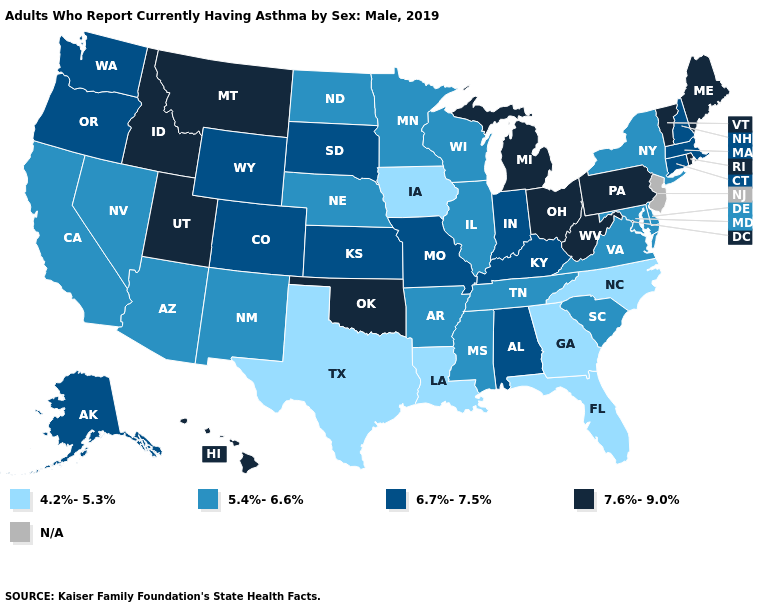What is the highest value in the West ?
Be succinct. 7.6%-9.0%. Name the states that have a value in the range 5.4%-6.6%?
Answer briefly. Arizona, Arkansas, California, Delaware, Illinois, Maryland, Minnesota, Mississippi, Nebraska, Nevada, New Mexico, New York, North Dakota, South Carolina, Tennessee, Virginia, Wisconsin. Name the states that have a value in the range 4.2%-5.3%?
Quick response, please. Florida, Georgia, Iowa, Louisiana, North Carolina, Texas. Among the states that border Mississippi , which have the highest value?
Short answer required. Alabama. Name the states that have a value in the range 5.4%-6.6%?
Quick response, please. Arizona, Arkansas, California, Delaware, Illinois, Maryland, Minnesota, Mississippi, Nebraska, Nevada, New Mexico, New York, North Dakota, South Carolina, Tennessee, Virginia, Wisconsin. Name the states that have a value in the range 6.7%-7.5%?
Keep it brief. Alabama, Alaska, Colorado, Connecticut, Indiana, Kansas, Kentucky, Massachusetts, Missouri, New Hampshire, Oregon, South Dakota, Washington, Wyoming. Which states have the lowest value in the MidWest?
Quick response, please. Iowa. How many symbols are there in the legend?
Keep it brief. 5. What is the value of Arkansas?
Short answer required. 5.4%-6.6%. Name the states that have a value in the range 5.4%-6.6%?
Be succinct. Arizona, Arkansas, California, Delaware, Illinois, Maryland, Minnesota, Mississippi, Nebraska, Nevada, New Mexico, New York, North Dakota, South Carolina, Tennessee, Virginia, Wisconsin. Does Michigan have the highest value in the USA?
Be succinct. Yes. Is the legend a continuous bar?
Short answer required. No. What is the value of South Dakota?
Give a very brief answer. 6.7%-7.5%. How many symbols are there in the legend?
Write a very short answer. 5. 